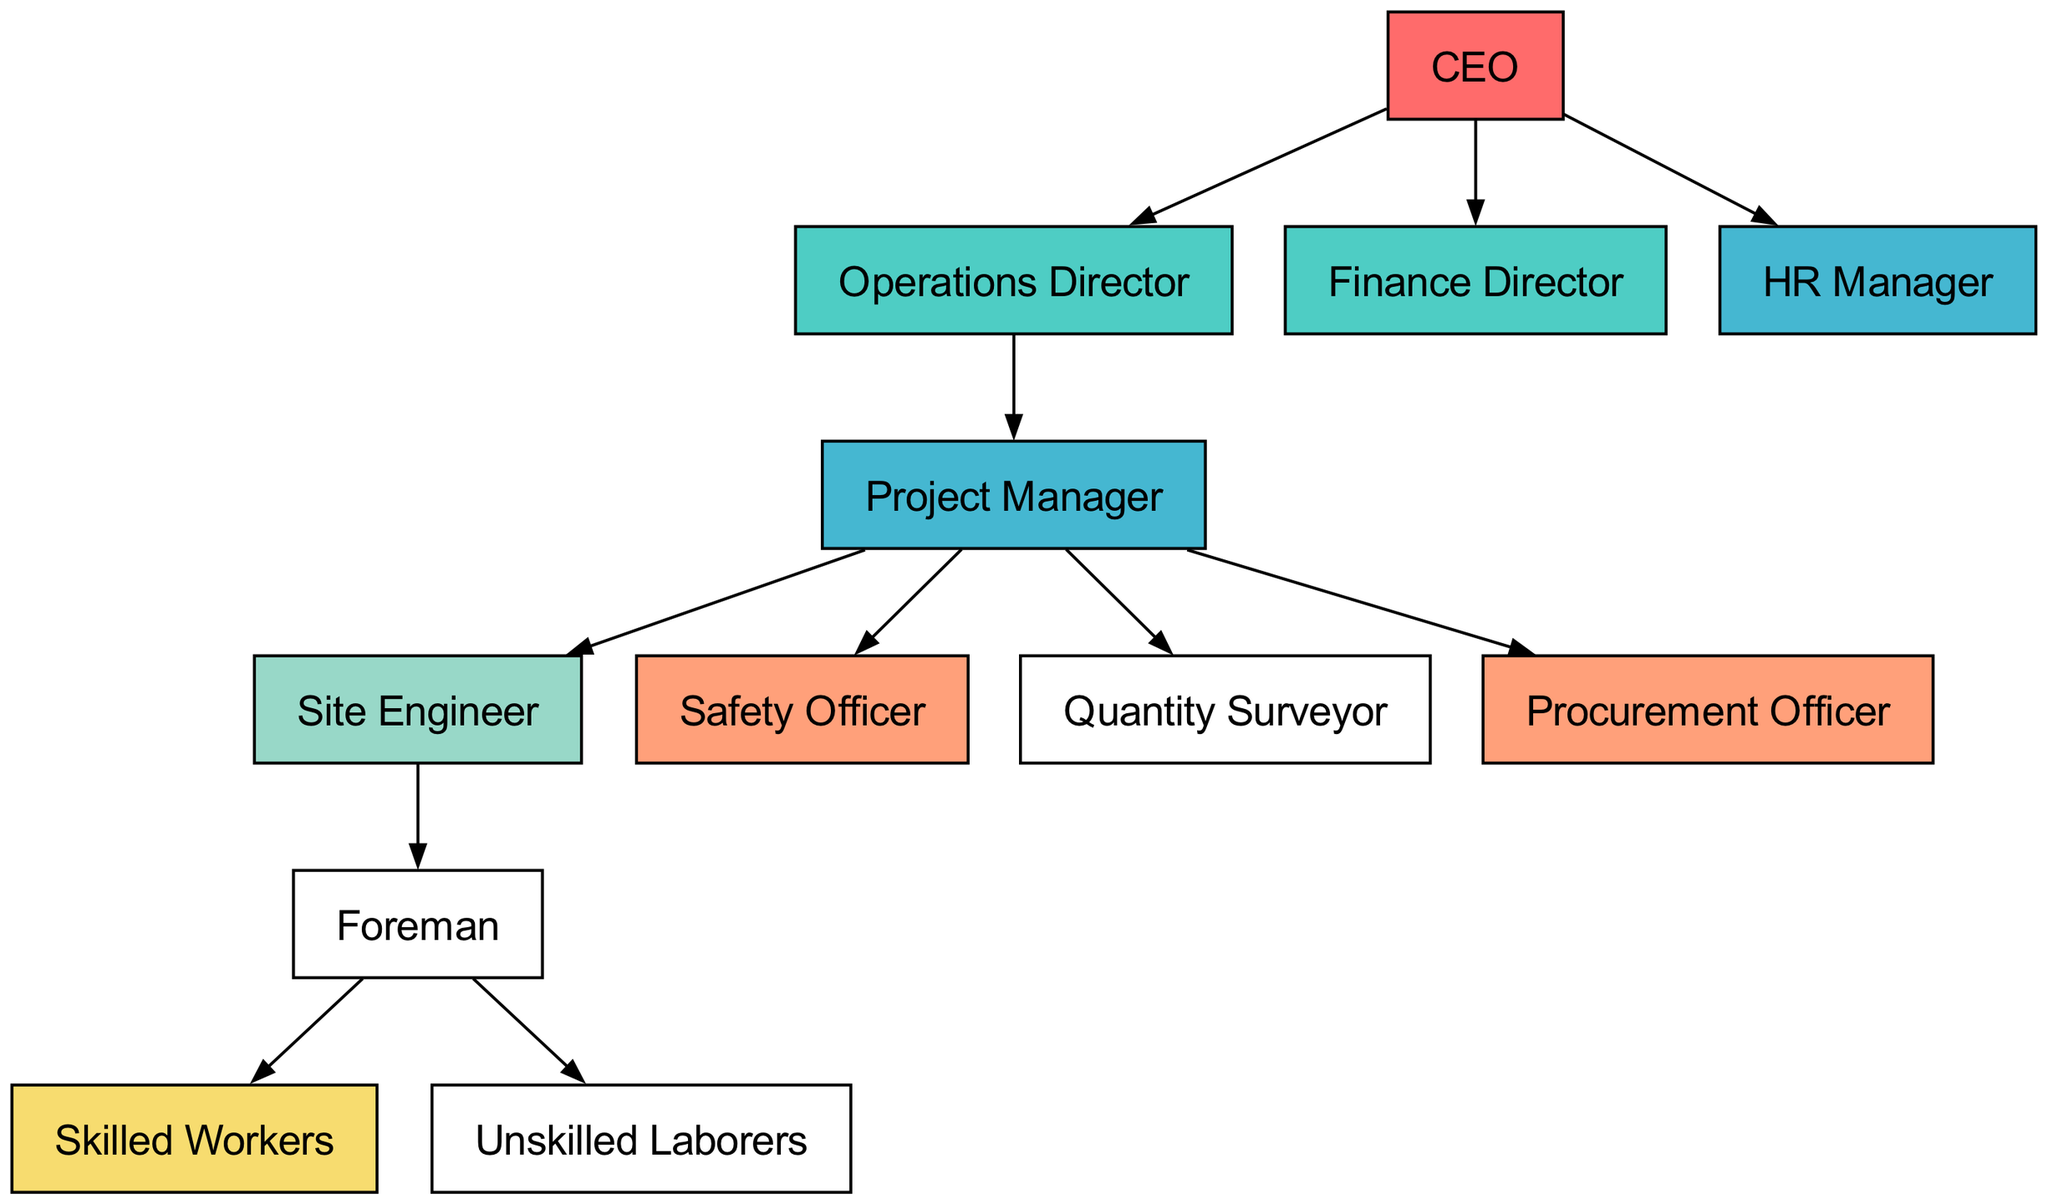What is the highest position in the hierarchy? The highest position is indicated by the topmost node in the diagram, which is labeled as "CEO."
Answer: CEO How many total nodes are present in the diagram? By counting all the different labeled boxes in the diagram, we find that there are 12 unique nodes.
Answer: 12 Who reports directly to the CEO? Looking at the edges directed from the "CEO" node, the nodes directly connected to it are "Operations Director," "Finance Director," and "HR Manager."
Answer: Operations Director, Finance Director, HR Manager Which position is directly below the Operations Director? The edge directed from "Operations Director" leads downwards to "Project Manager," indicating that the Project Manager directly reports to the Operations Director.
Answer: Project Manager What role does the Foreman manage? By examining the edges from "Foreman," we can see that it has directed edges going to "Skilled Workers" and "Unskilled Laborers," showing that Foreman manages both roles.
Answer: Skilled Workers, Unskilled Laborers How many positions report directly to the Project Manager? The edges that branch out from "Project Manager" show connections to "Site Engineer," "Safety Officer," "Quantity Surveyor," and "Procurement Officer," counting four in total.
Answer: 4 Who is at the bottom of the hierarchy? The nodes with no outgoing edges signify those at the bottom. In this case, the nodes "Skilled Workers" and "Unskilled Laborers" do not report to any other position.
Answer: Skilled Workers, Unskilled Laborers Which department has the most employees directly reporting under it? Analyzing the reporting structure, "Project Manager" has four direct reports (Site Engineer, Safety Officer, Quantity Surveyor, Procurement Officer), while the other managerial roles have fewer.
Answer: Project Manager Which role is responsible for safety on the construction site? The "Safety Officer" is directly connected to "Project Manager," indicating that this role is responsible for safety within the construction environment.
Answer: Safety Officer 